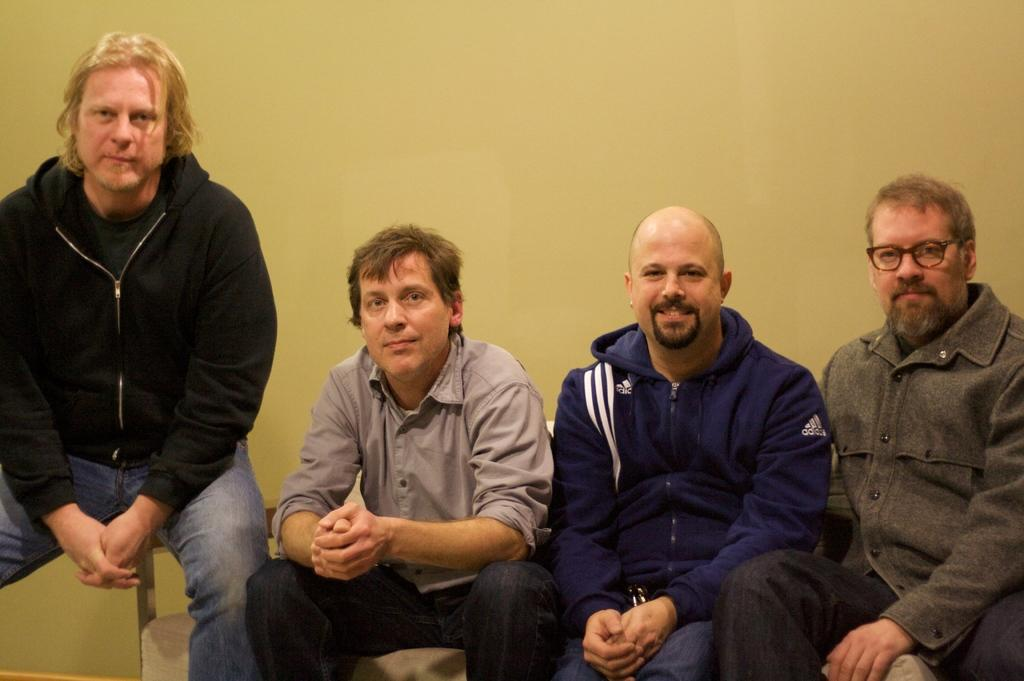How many people are in the image? There are four people in the image. What are the people doing in the image? The people are sitting on a sofa. Where is the sofa located in relation to the wall? The sofa is near a wall. Can you describe the object on a surface in the image? Unfortunately, the provided facts do not give any information about the object on a surface. What type of food is being served under the veil in the image? There is no food or veil present in the image. How is the division between the people on the sofa being maintained in the image? There is no mention of any division between the people on the sofa in the provided facts. 